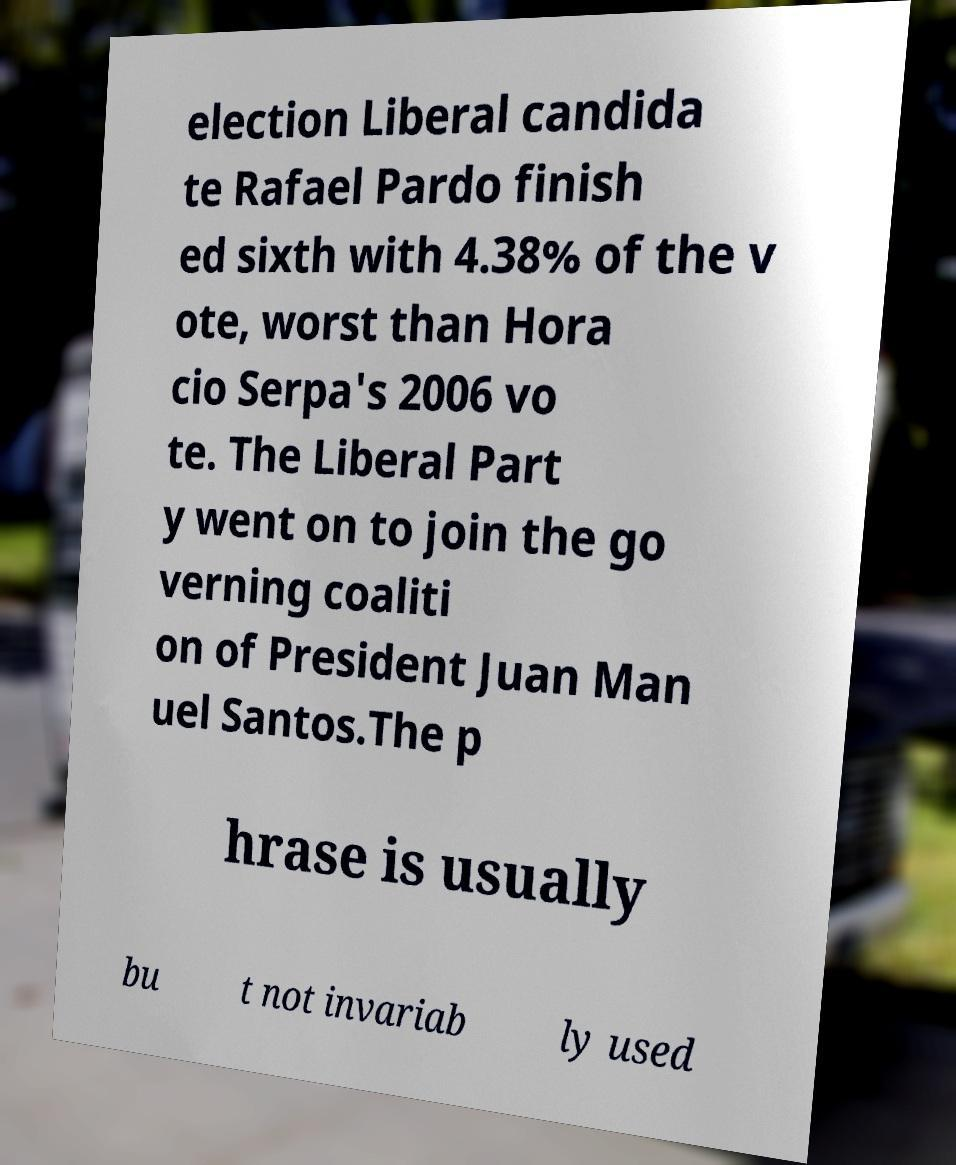Could you extract and type out the text from this image? election Liberal candida te Rafael Pardo finish ed sixth with 4.38% of the v ote, worst than Hora cio Serpa's 2006 vo te. The Liberal Part y went on to join the go verning coaliti on of President Juan Man uel Santos.The p hrase is usually bu t not invariab ly used 